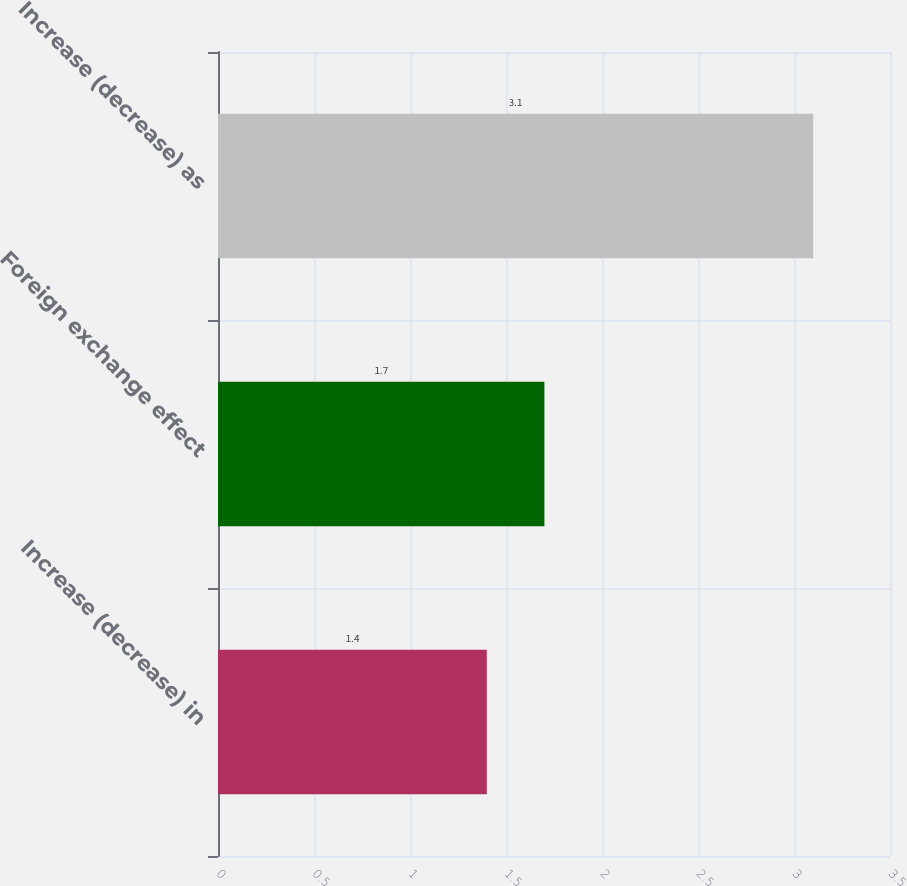<chart> <loc_0><loc_0><loc_500><loc_500><bar_chart><fcel>Increase (decrease) in<fcel>Foreign exchange effect<fcel>Increase (decrease) as<nl><fcel>1.4<fcel>1.7<fcel>3.1<nl></chart> 